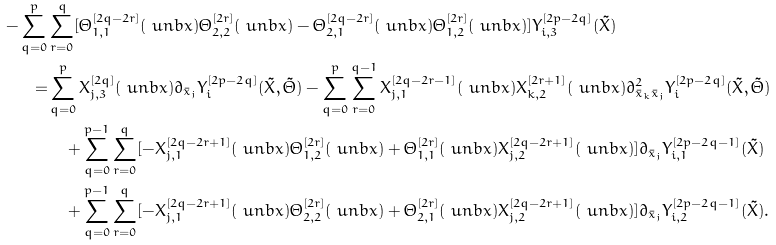Convert formula to latex. <formula><loc_0><loc_0><loc_500><loc_500>- \sum _ { q = 0 } ^ { p } & \sum _ { r = 0 } ^ { q } [ \Theta _ { 1 , 1 } ^ { [ 2 q - 2 r ] } ( \ u n b x ) \Theta _ { 2 , 2 } ^ { [ 2 r ] } ( \ u n b x ) - \Theta _ { 2 , 1 } ^ { [ 2 q - 2 r ] } ( \ u n b x ) \Theta _ { 1 , 2 } ^ { [ 2 r ] } ( \ u n b x ) ] Y _ { i , 3 } ^ { [ 2 p - 2 q ] } ( { \tilde { X } } ) \\ = & \sum _ { q = 0 } ^ { p } X _ { j , 3 } ^ { [ 2 q ] } ( \ u n b x ) \partial _ { \bar { x } _ { j } } Y _ { i } ^ { [ 2 p - 2 q ] } ( { \tilde { X } } , { \tilde { \Theta } } ) - \sum _ { q = 0 } ^ { p } \sum _ { r = 0 } ^ { q - 1 } X _ { j , 1 } ^ { [ 2 q - 2 r - 1 ] } ( \ u n b x ) X _ { k , 2 } ^ { [ 2 r + 1 ] } ( \ u n b x ) \partial ^ { 2 } _ { \bar { x } _ { k } \bar { x } _ { j } } Y _ { i } ^ { [ 2 p - 2 q ] } ( { \tilde { X } } , { \tilde { \Theta } } ) \\ & \quad + \sum _ { q = 0 } ^ { p - 1 } \sum _ { r = 0 } ^ { q } [ - X _ { j , 1 } ^ { [ 2 q - 2 r + 1 ] } ( \ u n b x ) \Theta _ { 1 , 2 } ^ { [ 2 r ] } ( \ u n b x ) + \Theta _ { 1 , 1 } ^ { [ 2 r ] } ( \ u n b x ) X _ { j , 2 } ^ { [ 2 q - 2 r + 1 ] } ( \ u n b x ) ] \partial _ { \bar { x } _ { j } } Y _ { i , 1 } ^ { [ 2 p - 2 q - 1 ] } ( { \tilde { X } } ) \\ & \quad + \sum _ { q = 0 } ^ { p - 1 } \sum _ { r = 0 } ^ { q } [ - X _ { j , 1 } ^ { [ 2 q - 2 r + 1 ] } ( \ u n b x ) \Theta _ { 2 , 2 } ^ { [ 2 r ] } ( \ u n b x ) + \Theta _ { 2 , 1 } ^ { [ 2 r ] } ( \ u n b x ) X _ { j , 2 } ^ { [ 2 q - 2 r + 1 ] } ( \ u n b x ) ] \partial _ { \bar { x } _ { j } } Y _ { i , 2 } ^ { [ 2 p - 2 q - 1 ] } ( { \tilde { X } } ) .</formula> 